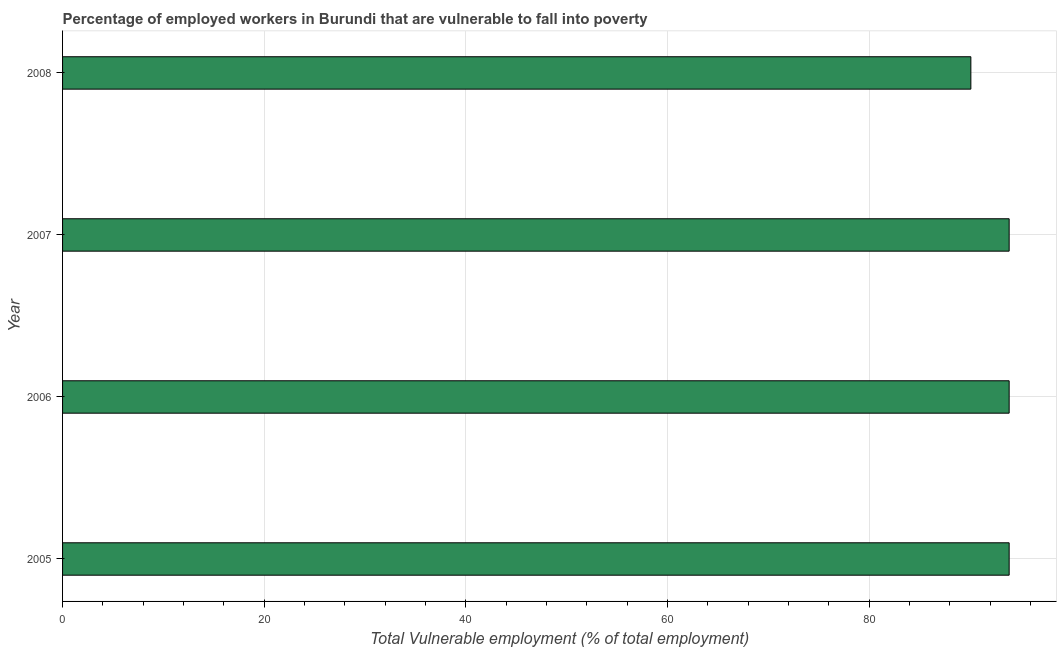What is the title of the graph?
Provide a succinct answer. Percentage of employed workers in Burundi that are vulnerable to fall into poverty. What is the label or title of the X-axis?
Offer a very short reply. Total Vulnerable employment (% of total employment). What is the label or title of the Y-axis?
Make the answer very short. Year. What is the total vulnerable employment in 2005?
Provide a short and direct response. 93.9. Across all years, what is the maximum total vulnerable employment?
Make the answer very short. 93.9. Across all years, what is the minimum total vulnerable employment?
Keep it short and to the point. 90.1. In which year was the total vulnerable employment maximum?
Give a very brief answer. 2005. In which year was the total vulnerable employment minimum?
Give a very brief answer. 2008. What is the sum of the total vulnerable employment?
Offer a very short reply. 371.8. What is the difference between the total vulnerable employment in 2005 and 2006?
Ensure brevity in your answer.  0. What is the average total vulnerable employment per year?
Ensure brevity in your answer.  92.95. What is the median total vulnerable employment?
Offer a very short reply. 93.9. What is the ratio of the total vulnerable employment in 2007 to that in 2008?
Make the answer very short. 1.04. Is the total vulnerable employment in 2006 less than that in 2008?
Make the answer very short. No. Is the difference between the total vulnerable employment in 2005 and 2006 greater than the difference between any two years?
Your response must be concise. No. What is the difference between the highest and the second highest total vulnerable employment?
Provide a short and direct response. 0. Is the sum of the total vulnerable employment in 2007 and 2008 greater than the maximum total vulnerable employment across all years?
Your answer should be very brief. Yes. In how many years, is the total vulnerable employment greater than the average total vulnerable employment taken over all years?
Offer a terse response. 3. What is the difference between two consecutive major ticks on the X-axis?
Offer a very short reply. 20. Are the values on the major ticks of X-axis written in scientific E-notation?
Ensure brevity in your answer.  No. What is the Total Vulnerable employment (% of total employment) of 2005?
Offer a very short reply. 93.9. What is the Total Vulnerable employment (% of total employment) in 2006?
Your answer should be very brief. 93.9. What is the Total Vulnerable employment (% of total employment) in 2007?
Keep it short and to the point. 93.9. What is the Total Vulnerable employment (% of total employment) in 2008?
Keep it short and to the point. 90.1. What is the difference between the Total Vulnerable employment (% of total employment) in 2005 and 2007?
Provide a succinct answer. 0. What is the difference between the Total Vulnerable employment (% of total employment) in 2006 and 2007?
Your answer should be very brief. 0. What is the difference between the Total Vulnerable employment (% of total employment) in 2006 and 2008?
Your answer should be compact. 3.8. What is the difference between the Total Vulnerable employment (% of total employment) in 2007 and 2008?
Keep it short and to the point. 3.8. What is the ratio of the Total Vulnerable employment (% of total employment) in 2005 to that in 2007?
Provide a short and direct response. 1. What is the ratio of the Total Vulnerable employment (% of total employment) in 2005 to that in 2008?
Provide a short and direct response. 1.04. What is the ratio of the Total Vulnerable employment (% of total employment) in 2006 to that in 2007?
Your response must be concise. 1. What is the ratio of the Total Vulnerable employment (% of total employment) in 2006 to that in 2008?
Ensure brevity in your answer.  1.04. What is the ratio of the Total Vulnerable employment (% of total employment) in 2007 to that in 2008?
Give a very brief answer. 1.04. 